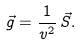Convert formula to latex. <formula><loc_0><loc_0><loc_500><loc_500>\vec { g } = \frac { 1 } { v ^ { 2 } } \, \vec { S } .</formula> 